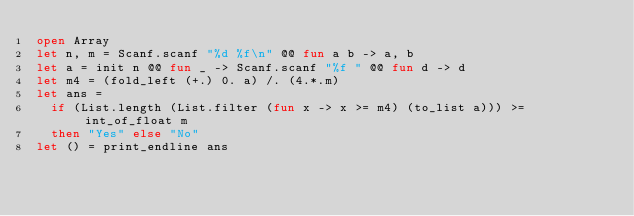<code> <loc_0><loc_0><loc_500><loc_500><_OCaml_>open Array
let n, m = Scanf.scanf "%d %f\n" @@ fun a b -> a, b
let a = init n @@ fun _ -> Scanf.scanf "%f " @@ fun d -> d
let m4 = (fold_left (+.) 0. a) /. (4.*.m)
let ans =
  if (List.length (List.filter (fun x -> x >= m4) (to_list a))) >= int_of_float m
  then "Yes" else "No"
let () = print_endline ans</code> 